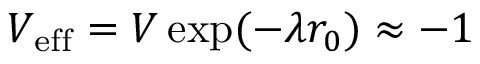Convert formula to latex. <formula><loc_0><loc_0><loc_500><loc_500>V _ { e f f } = V \exp ( - \lambda r _ { 0 } ) \approx - 1</formula> 